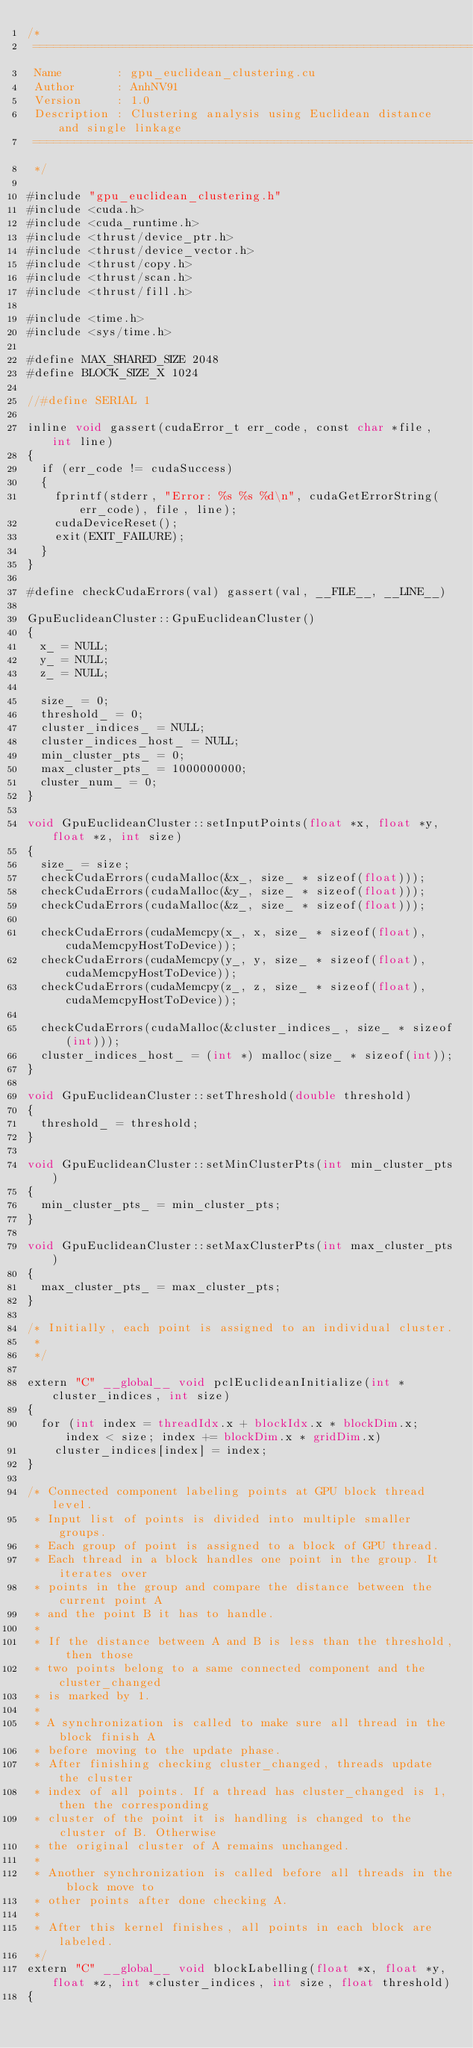<code> <loc_0><loc_0><loc_500><loc_500><_Cuda_>/*
 ============================================================================
 Name        : gpu_euclidean_clustering.cu
 Author      : AnhNV91
 Version     : 1.0
 Description : Clustering analysis using Euclidean distance and single linkage
 ============================================================================
 */

#include "gpu_euclidean_clustering.h"
#include <cuda.h>
#include <cuda_runtime.h>
#include <thrust/device_ptr.h>
#include <thrust/device_vector.h>
#include <thrust/copy.h>
#include <thrust/scan.h>
#include <thrust/fill.h>

#include <time.h>
#include <sys/time.h>

#define MAX_SHARED_SIZE 2048
#define BLOCK_SIZE_X 1024

//#define SERIAL 1

inline void gassert(cudaError_t err_code, const char *file, int line)
{
  if (err_code != cudaSuccess)
  {
    fprintf(stderr, "Error: %s %s %d\n", cudaGetErrorString(err_code), file, line);
    cudaDeviceReset();
    exit(EXIT_FAILURE);
  }
}

#define checkCudaErrors(val) gassert(val, __FILE__, __LINE__)

GpuEuclideanCluster::GpuEuclideanCluster()
{
  x_ = NULL;
  y_ = NULL;
  z_ = NULL;

  size_ = 0;
  threshold_ = 0;
  cluster_indices_ = NULL;
  cluster_indices_host_ = NULL;
  min_cluster_pts_ = 0;
  max_cluster_pts_ = 1000000000;
  cluster_num_ = 0;
}

void GpuEuclideanCluster::setInputPoints(float *x, float *y, float *z, int size)
{
  size_ = size;
  checkCudaErrors(cudaMalloc(&x_, size_ * sizeof(float)));
  checkCudaErrors(cudaMalloc(&y_, size_ * sizeof(float)));
  checkCudaErrors(cudaMalloc(&z_, size_ * sizeof(float)));

  checkCudaErrors(cudaMemcpy(x_, x, size_ * sizeof(float), cudaMemcpyHostToDevice));
  checkCudaErrors(cudaMemcpy(y_, y, size_ * sizeof(float), cudaMemcpyHostToDevice));
  checkCudaErrors(cudaMemcpy(z_, z, size_ * sizeof(float), cudaMemcpyHostToDevice));

  checkCudaErrors(cudaMalloc(&cluster_indices_, size_ * sizeof(int)));
  cluster_indices_host_ = (int *) malloc(size_ * sizeof(int));
}

void GpuEuclideanCluster::setThreshold(double threshold)
{
  threshold_ = threshold;
}

void GpuEuclideanCluster::setMinClusterPts(int min_cluster_pts)
{
  min_cluster_pts_ = min_cluster_pts;
}

void GpuEuclideanCluster::setMaxClusterPts(int max_cluster_pts)
{
  max_cluster_pts_ = max_cluster_pts;
}

/* Initially, each point is assigned to an individual cluster.
 *
 */

extern "C" __global__ void pclEuclideanInitialize(int *cluster_indices, int size)
{
  for (int index = threadIdx.x + blockIdx.x * blockDim.x; index < size; index += blockDim.x * gridDim.x)
    cluster_indices[index] = index;
}

/* Connected component labeling points at GPU block thread level.
 * Input list of points is divided into multiple smaller groups.
 * Each group of point is assigned to a block of GPU thread.
 * Each thread in a block handles one point in the group. It iterates over
 * points in the group and compare the distance between the current point A
 * and the point B it has to handle.
 *
 * If the distance between A and B is less than the threshold, then those
 * two points belong to a same connected component and the cluster_changed
 * is marked by 1.
 *
 * A synchronization is called to make sure all thread in the block finish A
 * before moving to the update phase.
 * After finishing checking cluster_changed, threads update the cluster
 * index of all points. If a thread has cluster_changed is 1, then the corresponding
 * cluster of the point it is handling is changed to the cluster of B. Otherwise
 * the original cluster of A remains unchanged.
 *
 * Another synchronization is called before all threads in the block move to
 * other points after done checking A.
 *
 * After this kernel finishes, all points in each block are labeled.
 */
extern "C" __global__ void blockLabelling(float *x, float *y, float *z, int *cluster_indices, int size, float threshold)
{</code> 